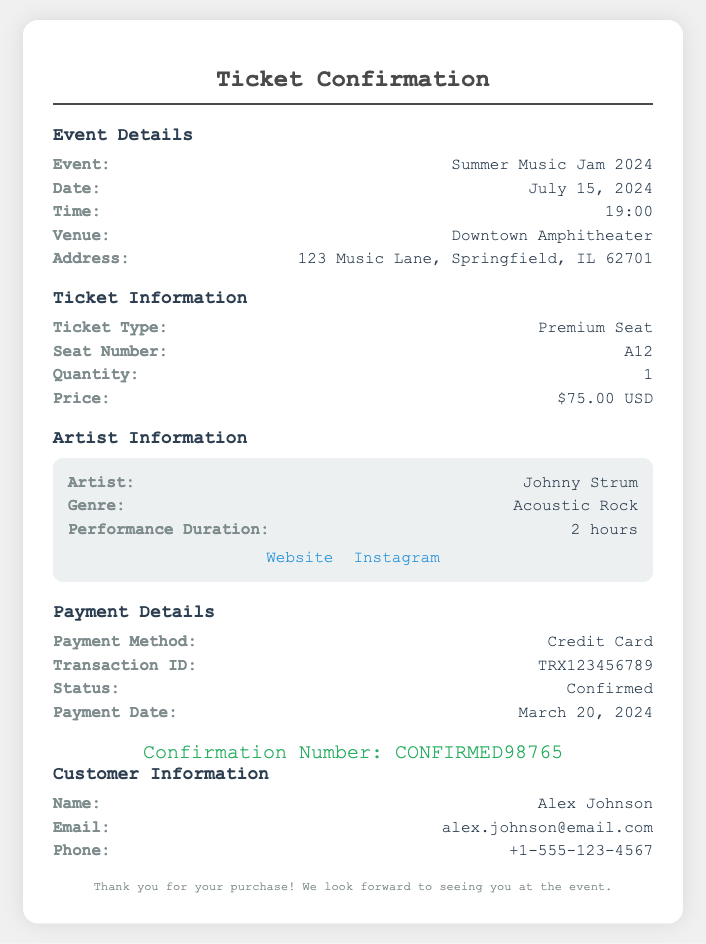What is the event name? The event name is clearly stated in the document under Event Details.
Answer: Summer Music Jam 2024 What is the seat number? The seat number is listed under Ticket Information, indicating the specific location for viewing the event.
Answer: A12 What is the price of the ticket? The price of the ticket is mentioned in the Ticket Information section alongside the ticket type and quantity.
Answer: $75.00 USD Who is the performing artist? The artist performing is given in the Artist Information section, which details about the performance.
Answer: Johnny Strum What is the date of the event? The date can be found in the Event Details section of the document, which specifies when the event will take place.
Answer: July 15, 2024 What payment method was used? The payment method used for the transaction is stated in the Payment Details section of the document.
Answer: Credit Card How long is the performance duration? The performance duration is provided in the Artist Information, indicating how long the artist will be performing.
Answer: 2 hours What is the confirmation number? The confirmation number is mentioned towards the end of the document, signifying the successful booking of the ticket.
Answer: CONFIRMED98765 Who is the customer listed? The customer information section identifies the individual who purchased the ticket.
Answer: Alex Johnson 